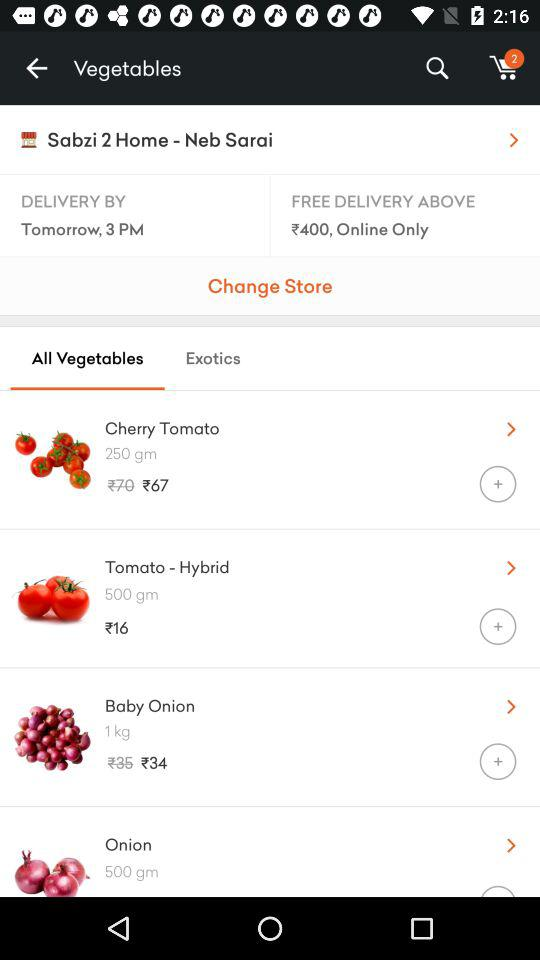When will it be delivered? It will be delivered tomorrow by 3 p.m. 